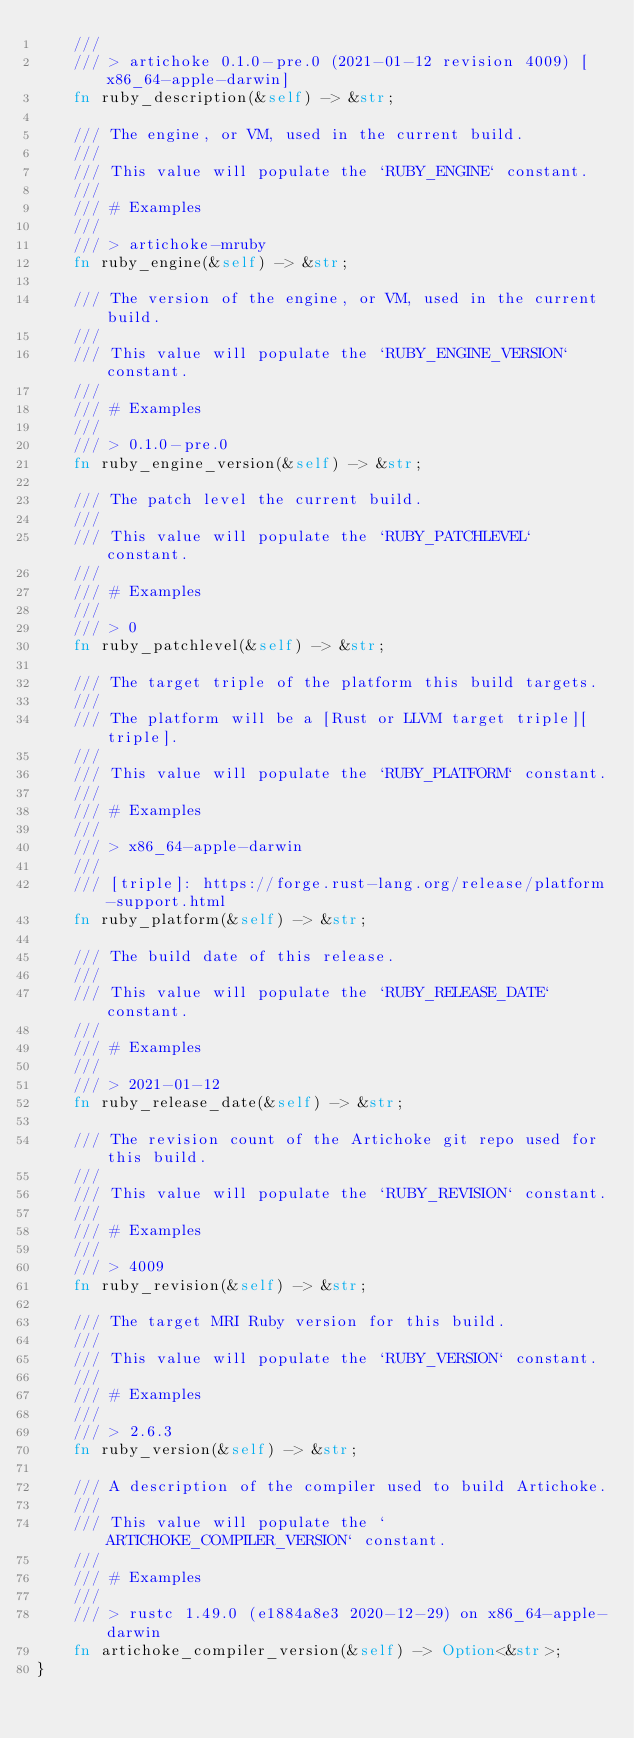Convert code to text. <code><loc_0><loc_0><loc_500><loc_500><_Rust_>    ///
    /// > artichoke 0.1.0-pre.0 (2021-01-12 revision 4009) [x86_64-apple-darwin]
    fn ruby_description(&self) -> &str;

    /// The engine, or VM, used in the current build.
    ///
    /// This value will populate the `RUBY_ENGINE` constant.
    ///
    /// # Examples
    ///
    /// > artichoke-mruby
    fn ruby_engine(&self) -> &str;

    /// The version of the engine, or VM, used in the current build.
    ///
    /// This value will populate the `RUBY_ENGINE_VERSION` constant.
    ///
    /// # Examples
    ///
    /// > 0.1.0-pre.0
    fn ruby_engine_version(&self) -> &str;

    /// The patch level the current build.
    ///
    /// This value will populate the `RUBY_PATCHLEVEL` constant.
    ///
    /// # Examples
    ///
    /// > 0
    fn ruby_patchlevel(&self) -> &str;

    /// The target triple of the platform this build targets.
    ///
    /// The platform will be a [Rust or LLVM target triple][triple].
    ///
    /// This value will populate the `RUBY_PLATFORM` constant.
    ///
    /// # Examples
    ///
    /// > x86_64-apple-darwin
    ///
    /// [triple]: https://forge.rust-lang.org/release/platform-support.html
    fn ruby_platform(&self) -> &str;

    /// The build date of this release.
    ///
    /// This value will populate the `RUBY_RELEASE_DATE` constant.
    ///
    /// # Examples
    ///
    /// > 2021-01-12
    fn ruby_release_date(&self) -> &str;

    /// The revision count of the Artichoke git repo used for this build.
    ///
    /// This value will populate the `RUBY_REVISION` constant.
    ///
    /// # Examples
    ///
    /// > 4009
    fn ruby_revision(&self) -> &str;

    /// The target MRI Ruby version for this build.
    ///
    /// This value will populate the `RUBY_VERSION` constant.
    ///
    /// # Examples
    ///
    /// > 2.6.3
    fn ruby_version(&self) -> &str;

    /// A description of the compiler used to build Artichoke.
    ///
    /// This value will populate the `ARTICHOKE_COMPILER_VERSION` constant.
    ///
    /// # Examples
    ///
    /// > rustc 1.49.0 (e1884a8e3 2020-12-29) on x86_64-apple-darwin
    fn artichoke_compiler_version(&self) -> Option<&str>;
}
</code> 